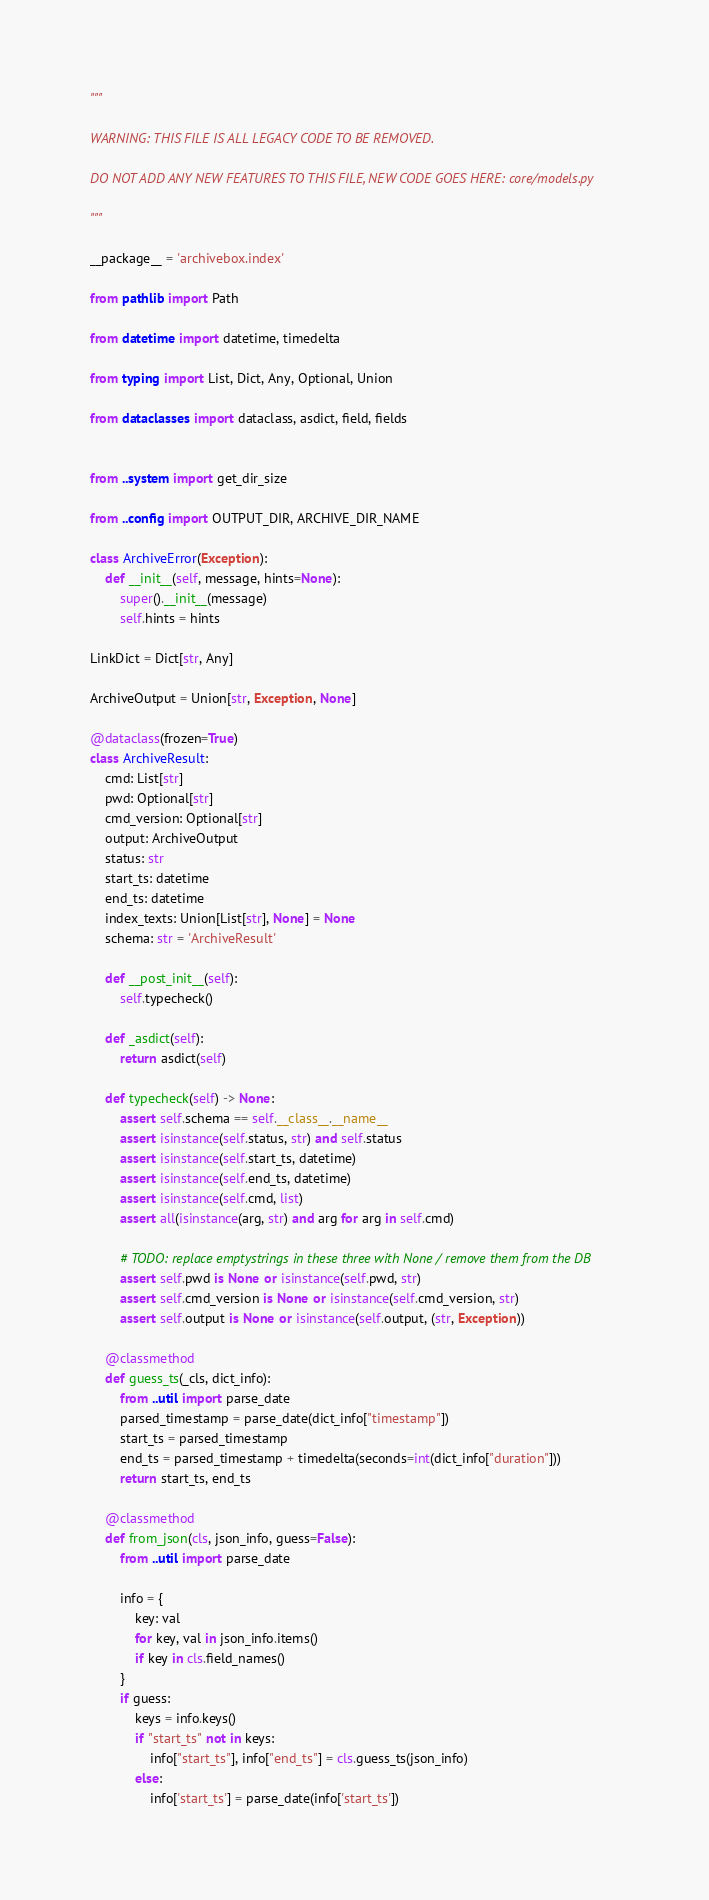Convert code to text. <code><loc_0><loc_0><loc_500><loc_500><_Python_>"""

WARNING: THIS FILE IS ALL LEGACY CODE TO BE REMOVED.

DO NOT ADD ANY NEW FEATURES TO THIS FILE, NEW CODE GOES HERE: core/models.py

"""

__package__ = 'archivebox.index'

from pathlib import Path

from datetime import datetime, timedelta

from typing import List, Dict, Any, Optional, Union

from dataclasses import dataclass, asdict, field, fields


from ..system import get_dir_size

from ..config import OUTPUT_DIR, ARCHIVE_DIR_NAME

class ArchiveError(Exception):
    def __init__(self, message, hints=None):
        super().__init__(message)
        self.hints = hints

LinkDict = Dict[str, Any]

ArchiveOutput = Union[str, Exception, None]

@dataclass(frozen=True)
class ArchiveResult:
    cmd: List[str]
    pwd: Optional[str]
    cmd_version: Optional[str]
    output: ArchiveOutput
    status: str
    start_ts: datetime
    end_ts: datetime
    index_texts: Union[List[str], None] = None
    schema: str = 'ArchiveResult'

    def __post_init__(self):
        self.typecheck()

    def _asdict(self):
        return asdict(self)

    def typecheck(self) -> None:
        assert self.schema == self.__class__.__name__
        assert isinstance(self.status, str) and self.status
        assert isinstance(self.start_ts, datetime)
        assert isinstance(self.end_ts, datetime)
        assert isinstance(self.cmd, list)
        assert all(isinstance(arg, str) and arg for arg in self.cmd)

        # TODO: replace emptystrings in these three with None / remove them from the DB
        assert self.pwd is None or isinstance(self.pwd, str)
        assert self.cmd_version is None or isinstance(self.cmd_version, str)
        assert self.output is None or isinstance(self.output, (str, Exception))

    @classmethod
    def guess_ts(_cls, dict_info):
        from ..util import parse_date
        parsed_timestamp = parse_date(dict_info["timestamp"])
        start_ts = parsed_timestamp
        end_ts = parsed_timestamp + timedelta(seconds=int(dict_info["duration"]))
        return start_ts, end_ts

    @classmethod
    def from_json(cls, json_info, guess=False):
        from ..util import parse_date

        info = {
            key: val
            for key, val in json_info.items()
            if key in cls.field_names()
        }
        if guess:
            keys = info.keys()
            if "start_ts" not in keys:
                info["start_ts"], info["end_ts"] = cls.guess_ts(json_info)
            else:
                info['start_ts'] = parse_date(info['start_ts'])</code> 